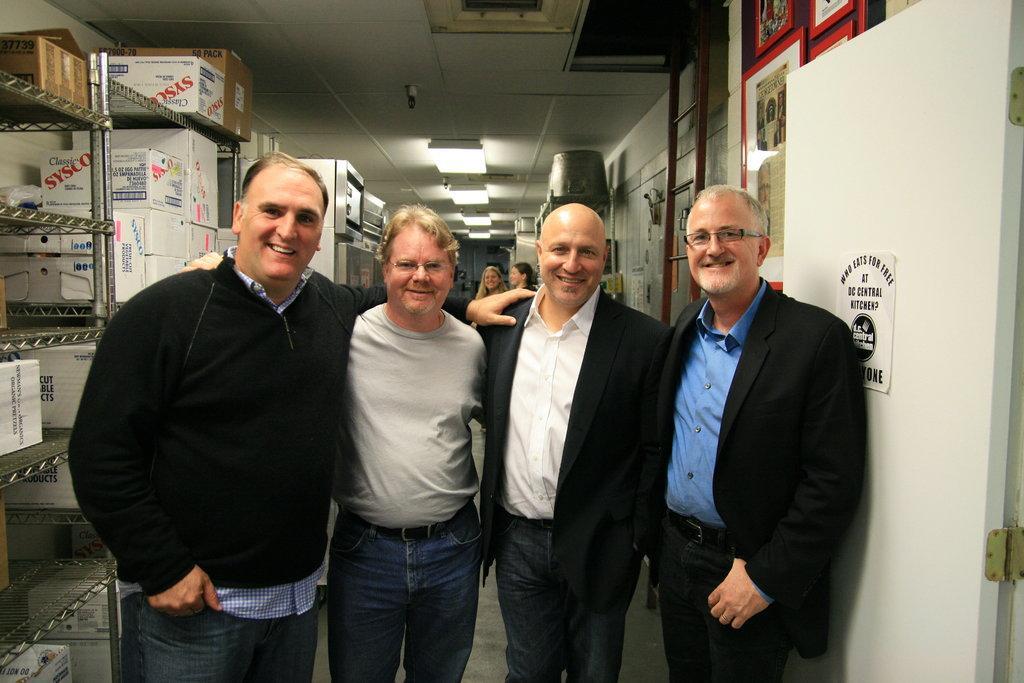In one or two sentences, can you explain what this image depicts? In front of the picture, we see four men are standing. All of them are smiling and they are posing for the photo. Beside them, we see a white door on which a poster is pasted. On the left side, we see the racks in which the carton boxes which are in brown and white color are placed. Behind them, we see two women are standing. On the right side, we see a wall on which the photo frames and the posters are pasted. In the background, we see a white color object and a grey color wall. At the top, we see the lights and the ceiling of the room. 